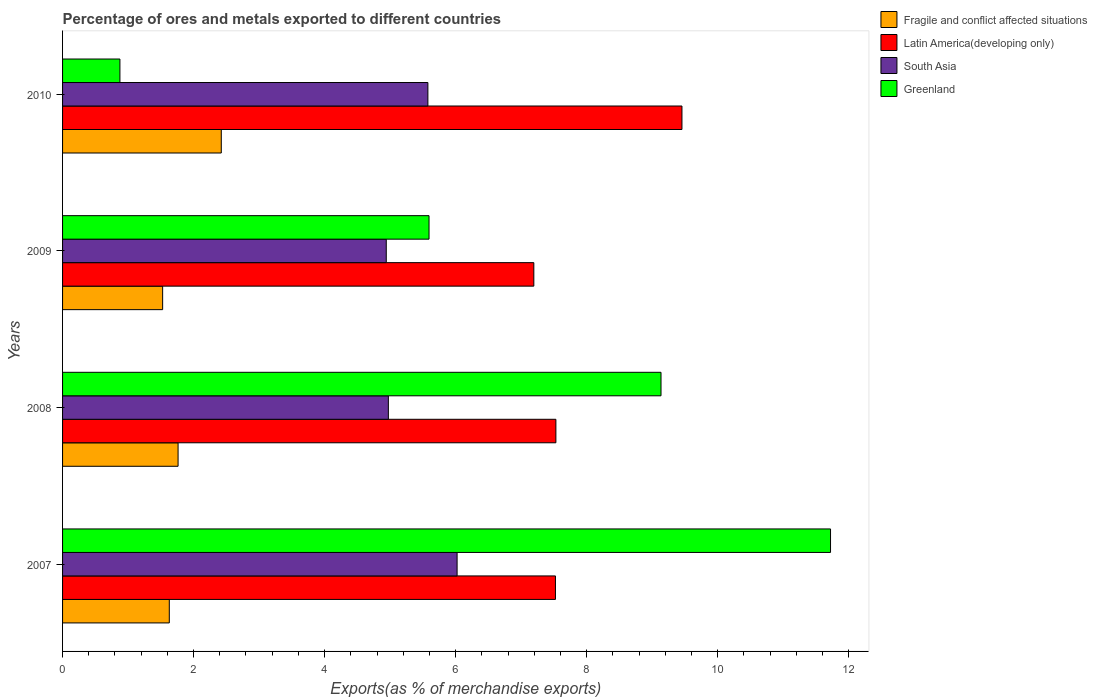How many different coloured bars are there?
Keep it short and to the point. 4. How many bars are there on the 3rd tick from the bottom?
Your answer should be compact. 4. What is the label of the 2nd group of bars from the top?
Offer a very short reply. 2009. In how many cases, is the number of bars for a given year not equal to the number of legend labels?
Provide a short and direct response. 0. What is the percentage of exports to different countries in Latin America(developing only) in 2009?
Your response must be concise. 7.19. Across all years, what is the maximum percentage of exports to different countries in Greenland?
Give a very brief answer. 11.72. Across all years, what is the minimum percentage of exports to different countries in Fragile and conflict affected situations?
Your response must be concise. 1.53. What is the total percentage of exports to different countries in South Asia in the graph?
Your response must be concise. 21.51. What is the difference between the percentage of exports to different countries in South Asia in 2009 and that in 2010?
Provide a short and direct response. -0.64. What is the difference between the percentage of exports to different countries in Fragile and conflict affected situations in 2010 and the percentage of exports to different countries in South Asia in 2007?
Offer a very short reply. -3.6. What is the average percentage of exports to different countries in Fragile and conflict affected situations per year?
Keep it short and to the point. 1.84. In the year 2007, what is the difference between the percentage of exports to different countries in Latin America(developing only) and percentage of exports to different countries in Fragile and conflict affected situations?
Ensure brevity in your answer.  5.89. What is the ratio of the percentage of exports to different countries in Latin America(developing only) in 2008 to that in 2009?
Provide a short and direct response. 1.05. What is the difference between the highest and the second highest percentage of exports to different countries in Fragile and conflict affected situations?
Your answer should be very brief. 0.66. What is the difference between the highest and the lowest percentage of exports to different countries in South Asia?
Provide a short and direct response. 1.08. In how many years, is the percentage of exports to different countries in Greenland greater than the average percentage of exports to different countries in Greenland taken over all years?
Ensure brevity in your answer.  2. What does the 1st bar from the top in 2010 represents?
Provide a short and direct response. Greenland. What does the 2nd bar from the bottom in 2007 represents?
Keep it short and to the point. Latin America(developing only). How many years are there in the graph?
Offer a very short reply. 4. Are the values on the major ticks of X-axis written in scientific E-notation?
Make the answer very short. No. Does the graph contain any zero values?
Ensure brevity in your answer.  No. Does the graph contain grids?
Offer a terse response. No. How are the legend labels stacked?
Give a very brief answer. Vertical. What is the title of the graph?
Offer a terse response. Percentage of ores and metals exported to different countries. What is the label or title of the X-axis?
Keep it short and to the point. Exports(as % of merchandise exports). What is the label or title of the Y-axis?
Offer a terse response. Years. What is the Exports(as % of merchandise exports) in Fragile and conflict affected situations in 2007?
Ensure brevity in your answer.  1.63. What is the Exports(as % of merchandise exports) of Latin America(developing only) in 2007?
Offer a terse response. 7.52. What is the Exports(as % of merchandise exports) in South Asia in 2007?
Your answer should be very brief. 6.02. What is the Exports(as % of merchandise exports) of Greenland in 2007?
Your response must be concise. 11.72. What is the Exports(as % of merchandise exports) in Fragile and conflict affected situations in 2008?
Ensure brevity in your answer.  1.76. What is the Exports(as % of merchandise exports) of Latin America(developing only) in 2008?
Give a very brief answer. 7.53. What is the Exports(as % of merchandise exports) in South Asia in 2008?
Provide a succinct answer. 4.97. What is the Exports(as % of merchandise exports) in Greenland in 2008?
Offer a very short reply. 9.14. What is the Exports(as % of merchandise exports) of Fragile and conflict affected situations in 2009?
Offer a terse response. 1.53. What is the Exports(as % of merchandise exports) of Latin America(developing only) in 2009?
Offer a very short reply. 7.19. What is the Exports(as % of merchandise exports) of South Asia in 2009?
Keep it short and to the point. 4.94. What is the Exports(as % of merchandise exports) of Greenland in 2009?
Offer a terse response. 5.59. What is the Exports(as % of merchandise exports) in Fragile and conflict affected situations in 2010?
Your response must be concise. 2.42. What is the Exports(as % of merchandise exports) of Latin America(developing only) in 2010?
Your answer should be very brief. 9.46. What is the Exports(as % of merchandise exports) in South Asia in 2010?
Offer a terse response. 5.58. What is the Exports(as % of merchandise exports) in Greenland in 2010?
Keep it short and to the point. 0.88. Across all years, what is the maximum Exports(as % of merchandise exports) of Fragile and conflict affected situations?
Provide a succinct answer. 2.42. Across all years, what is the maximum Exports(as % of merchandise exports) in Latin America(developing only)?
Provide a succinct answer. 9.46. Across all years, what is the maximum Exports(as % of merchandise exports) in South Asia?
Your response must be concise. 6.02. Across all years, what is the maximum Exports(as % of merchandise exports) of Greenland?
Keep it short and to the point. 11.72. Across all years, what is the minimum Exports(as % of merchandise exports) of Fragile and conflict affected situations?
Make the answer very short. 1.53. Across all years, what is the minimum Exports(as % of merchandise exports) in Latin America(developing only)?
Offer a terse response. 7.19. Across all years, what is the minimum Exports(as % of merchandise exports) in South Asia?
Ensure brevity in your answer.  4.94. Across all years, what is the minimum Exports(as % of merchandise exports) in Greenland?
Keep it short and to the point. 0.88. What is the total Exports(as % of merchandise exports) in Fragile and conflict affected situations in the graph?
Provide a succinct answer. 7.34. What is the total Exports(as % of merchandise exports) in Latin America(developing only) in the graph?
Your response must be concise. 31.7. What is the total Exports(as % of merchandise exports) in South Asia in the graph?
Provide a succinct answer. 21.51. What is the total Exports(as % of merchandise exports) in Greenland in the graph?
Your answer should be very brief. 27.33. What is the difference between the Exports(as % of merchandise exports) of Fragile and conflict affected situations in 2007 and that in 2008?
Ensure brevity in your answer.  -0.13. What is the difference between the Exports(as % of merchandise exports) in Latin America(developing only) in 2007 and that in 2008?
Your response must be concise. -0.01. What is the difference between the Exports(as % of merchandise exports) of South Asia in 2007 and that in 2008?
Offer a terse response. 1.05. What is the difference between the Exports(as % of merchandise exports) of Greenland in 2007 and that in 2008?
Your answer should be very brief. 2.59. What is the difference between the Exports(as % of merchandise exports) in Fragile and conflict affected situations in 2007 and that in 2009?
Ensure brevity in your answer.  0.1. What is the difference between the Exports(as % of merchandise exports) of Latin America(developing only) in 2007 and that in 2009?
Provide a short and direct response. 0.33. What is the difference between the Exports(as % of merchandise exports) of South Asia in 2007 and that in 2009?
Offer a very short reply. 1.08. What is the difference between the Exports(as % of merchandise exports) in Greenland in 2007 and that in 2009?
Provide a short and direct response. 6.13. What is the difference between the Exports(as % of merchandise exports) in Fragile and conflict affected situations in 2007 and that in 2010?
Provide a succinct answer. -0.79. What is the difference between the Exports(as % of merchandise exports) of Latin America(developing only) in 2007 and that in 2010?
Your answer should be compact. -1.93. What is the difference between the Exports(as % of merchandise exports) of South Asia in 2007 and that in 2010?
Keep it short and to the point. 0.45. What is the difference between the Exports(as % of merchandise exports) of Greenland in 2007 and that in 2010?
Provide a succinct answer. 10.85. What is the difference between the Exports(as % of merchandise exports) of Fragile and conflict affected situations in 2008 and that in 2009?
Give a very brief answer. 0.24. What is the difference between the Exports(as % of merchandise exports) in Latin America(developing only) in 2008 and that in 2009?
Make the answer very short. 0.34. What is the difference between the Exports(as % of merchandise exports) in South Asia in 2008 and that in 2009?
Make the answer very short. 0.03. What is the difference between the Exports(as % of merchandise exports) in Greenland in 2008 and that in 2009?
Offer a very short reply. 3.54. What is the difference between the Exports(as % of merchandise exports) in Fragile and conflict affected situations in 2008 and that in 2010?
Offer a very short reply. -0.66. What is the difference between the Exports(as % of merchandise exports) in Latin America(developing only) in 2008 and that in 2010?
Give a very brief answer. -1.92. What is the difference between the Exports(as % of merchandise exports) in South Asia in 2008 and that in 2010?
Ensure brevity in your answer.  -0.6. What is the difference between the Exports(as % of merchandise exports) of Greenland in 2008 and that in 2010?
Make the answer very short. 8.26. What is the difference between the Exports(as % of merchandise exports) of Fragile and conflict affected situations in 2009 and that in 2010?
Offer a terse response. -0.9. What is the difference between the Exports(as % of merchandise exports) in Latin America(developing only) in 2009 and that in 2010?
Offer a very short reply. -2.26. What is the difference between the Exports(as % of merchandise exports) of South Asia in 2009 and that in 2010?
Offer a very short reply. -0.64. What is the difference between the Exports(as % of merchandise exports) in Greenland in 2009 and that in 2010?
Offer a very short reply. 4.72. What is the difference between the Exports(as % of merchandise exports) in Fragile and conflict affected situations in 2007 and the Exports(as % of merchandise exports) in Latin America(developing only) in 2008?
Provide a short and direct response. -5.9. What is the difference between the Exports(as % of merchandise exports) in Fragile and conflict affected situations in 2007 and the Exports(as % of merchandise exports) in South Asia in 2008?
Your answer should be compact. -3.34. What is the difference between the Exports(as % of merchandise exports) of Fragile and conflict affected situations in 2007 and the Exports(as % of merchandise exports) of Greenland in 2008?
Ensure brevity in your answer.  -7.51. What is the difference between the Exports(as % of merchandise exports) in Latin America(developing only) in 2007 and the Exports(as % of merchandise exports) in South Asia in 2008?
Your response must be concise. 2.55. What is the difference between the Exports(as % of merchandise exports) of Latin America(developing only) in 2007 and the Exports(as % of merchandise exports) of Greenland in 2008?
Ensure brevity in your answer.  -1.61. What is the difference between the Exports(as % of merchandise exports) of South Asia in 2007 and the Exports(as % of merchandise exports) of Greenland in 2008?
Offer a terse response. -3.11. What is the difference between the Exports(as % of merchandise exports) in Fragile and conflict affected situations in 2007 and the Exports(as % of merchandise exports) in Latin America(developing only) in 2009?
Your response must be concise. -5.56. What is the difference between the Exports(as % of merchandise exports) in Fragile and conflict affected situations in 2007 and the Exports(as % of merchandise exports) in South Asia in 2009?
Your answer should be compact. -3.31. What is the difference between the Exports(as % of merchandise exports) of Fragile and conflict affected situations in 2007 and the Exports(as % of merchandise exports) of Greenland in 2009?
Your response must be concise. -3.96. What is the difference between the Exports(as % of merchandise exports) in Latin America(developing only) in 2007 and the Exports(as % of merchandise exports) in South Asia in 2009?
Your answer should be very brief. 2.58. What is the difference between the Exports(as % of merchandise exports) in Latin America(developing only) in 2007 and the Exports(as % of merchandise exports) in Greenland in 2009?
Provide a succinct answer. 1.93. What is the difference between the Exports(as % of merchandise exports) of South Asia in 2007 and the Exports(as % of merchandise exports) of Greenland in 2009?
Your answer should be very brief. 0.43. What is the difference between the Exports(as % of merchandise exports) in Fragile and conflict affected situations in 2007 and the Exports(as % of merchandise exports) in Latin America(developing only) in 2010?
Offer a terse response. -7.83. What is the difference between the Exports(as % of merchandise exports) of Fragile and conflict affected situations in 2007 and the Exports(as % of merchandise exports) of South Asia in 2010?
Your answer should be very brief. -3.95. What is the difference between the Exports(as % of merchandise exports) in Fragile and conflict affected situations in 2007 and the Exports(as % of merchandise exports) in Greenland in 2010?
Provide a succinct answer. 0.75. What is the difference between the Exports(as % of merchandise exports) in Latin America(developing only) in 2007 and the Exports(as % of merchandise exports) in South Asia in 2010?
Ensure brevity in your answer.  1.95. What is the difference between the Exports(as % of merchandise exports) in Latin America(developing only) in 2007 and the Exports(as % of merchandise exports) in Greenland in 2010?
Provide a short and direct response. 6.65. What is the difference between the Exports(as % of merchandise exports) of South Asia in 2007 and the Exports(as % of merchandise exports) of Greenland in 2010?
Offer a terse response. 5.15. What is the difference between the Exports(as % of merchandise exports) in Fragile and conflict affected situations in 2008 and the Exports(as % of merchandise exports) in Latin America(developing only) in 2009?
Offer a terse response. -5.43. What is the difference between the Exports(as % of merchandise exports) in Fragile and conflict affected situations in 2008 and the Exports(as % of merchandise exports) in South Asia in 2009?
Your response must be concise. -3.18. What is the difference between the Exports(as % of merchandise exports) in Fragile and conflict affected situations in 2008 and the Exports(as % of merchandise exports) in Greenland in 2009?
Your answer should be very brief. -3.83. What is the difference between the Exports(as % of merchandise exports) in Latin America(developing only) in 2008 and the Exports(as % of merchandise exports) in South Asia in 2009?
Your response must be concise. 2.59. What is the difference between the Exports(as % of merchandise exports) of Latin America(developing only) in 2008 and the Exports(as % of merchandise exports) of Greenland in 2009?
Offer a terse response. 1.94. What is the difference between the Exports(as % of merchandise exports) in South Asia in 2008 and the Exports(as % of merchandise exports) in Greenland in 2009?
Provide a short and direct response. -0.62. What is the difference between the Exports(as % of merchandise exports) of Fragile and conflict affected situations in 2008 and the Exports(as % of merchandise exports) of Latin America(developing only) in 2010?
Give a very brief answer. -7.69. What is the difference between the Exports(as % of merchandise exports) of Fragile and conflict affected situations in 2008 and the Exports(as % of merchandise exports) of South Asia in 2010?
Your answer should be compact. -3.81. What is the difference between the Exports(as % of merchandise exports) in Fragile and conflict affected situations in 2008 and the Exports(as % of merchandise exports) in Greenland in 2010?
Offer a very short reply. 0.89. What is the difference between the Exports(as % of merchandise exports) of Latin America(developing only) in 2008 and the Exports(as % of merchandise exports) of South Asia in 2010?
Keep it short and to the point. 1.95. What is the difference between the Exports(as % of merchandise exports) of Latin America(developing only) in 2008 and the Exports(as % of merchandise exports) of Greenland in 2010?
Give a very brief answer. 6.66. What is the difference between the Exports(as % of merchandise exports) in South Asia in 2008 and the Exports(as % of merchandise exports) in Greenland in 2010?
Provide a short and direct response. 4.1. What is the difference between the Exports(as % of merchandise exports) in Fragile and conflict affected situations in 2009 and the Exports(as % of merchandise exports) in Latin America(developing only) in 2010?
Your answer should be compact. -7.93. What is the difference between the Exports(as % of merchandise exports) of Fragile and conflict affected situations in 2009 and the Exports(as % of merchandise exports) of South Asia in 2010?
Keep it short and to the point. -4.05. What is the difference between the Exports(as % of merchandise exports) in Fragile and conflict affected situations in 2009 and the Exports(as % of merchandise exports) in Greenland in 2010?
Offer a very short reply. 0.65. What is the difference between the Exports(as % of merchandise exports) in Latin America(developing only) in 2009 and the Exports(as % of merchandise exports) in South Asia in 2010?
Your answer should be very brief. 1.62. What is the difference between the Exports(as % of merchandise exports) in Latin America(developing only) in 2009 and the Exports(as % of merchandise exports) in Greenland in 2010?
Provide a succinct answer. 6.32. What is the difference between the Exports(as % of merchandise exports) of South Asia in 2009 and the Exports(as % of merchandise exports) of Greenland in 2010?
Provide a succinct answer. 4.07. What is the average Exports(as % of merchandise exports) in Fragile and conflict affected situations per year?
Offer a terse response. 1.84. What is the average Exports(as % of merchandise exports) in Latin America(developing only) per year?
Provide a short and direct response. 7.93. What is the average Exports(as % of merchandise exports) of South Asia per year?
Make the answer very short. 5.38. What is the average Exports(as % of merchandise exports) of Greenland per year?
Make the answer very short. 6.83. In the year 2007, what is the difference between the Exports(as % of merchandise exports) of Fragile and conflict affected situations and Exports(as % of merchandise exports) of Latin America(developing only)?
Your response must be concise. -5.89. In the year 2007, what is the difference between the Exports(as % of merchandise exports) in Fragile and conflict affected situations and Exports(as % of merchandise exports) in South Asia?
Provide a succinct answer. -4.39. In the year 2007, what is the difference between the Exports(as % of merchandise exports) in Fragile and conflict affected situations and Exports(as % of merchandise exports) in Greenland?
Your response must be concise. -10.09. In the year 2007, what is the difference between the Exports(as % of merchandise exports) of Latin America(developing only) and Exports(as % of merchandise exports) of South Asia?
Keep it short and to the point. 1.5. In the year 2007, what is the difference between the Exports(as % of merchandise exports) of Latin America(developing only) and Exports(as % of merchandise exports) of Greenland?
Give a very brief answer. -4.2. In the year 2007, what is the difference between the Exports(as % of merchandise exports) in South Asia and Exports(as % of merchandise exports) in Greenland?
Offer a terse response. -5.7. In the year 2008, what is the difference between the Exports(as % of merchandise exports) in Fragile and conflict affected situations and Exports(as % of merchandise exports) in Latin America(developing only)?
Your answer should be very brief. -5.77. In the year 2008, what is the difference between the Exports(as % of merchandise exports) in Fragile and conflict affected situations and Exports(as % of merchandise exports) in South Asia?
Your answer should be very brief. -3.21. In the year 2008, what is the difference between the Exports(as % of merchandise exports) in Fragile and conflict affected situations and Exports(as % of merchandise exports) in Greenland?
Your response must be concise. -7.37. In the year 2008, what is the difference between the Exports(as % of merchandise exports) of Latin America(developing only) and Exports(as % of merchandise exports) of South Asia?
Provide a succinct answer. 2.56. In the year 2008, what is the difference between the Exports(as % of merchandise exports) of Latin America(developing only) and Exports(as % of merchandise exports) of Greenland?
Provide a short and direct response. -1.6. In the year 2008, what is the difference between the Exports(as % of merchandise exports) of South Asia and Exports(as % of merchandise exports) of Greenland?
Offer a very short reply. -4.16. In the year 2009, what is the difference between the Exports(as % of merchandise exports) of Fragile and conflict affected situations and Exports(as % of merchandise exports) of Latin America(developing only)?
Provide a short and direct response. -5.67. In the year 2009, what is the difference between the Exports(as % of merchandise exports) in Fragile and conflict affected situations and Exports(as % of merchandise exports) in South Asia?
Give a very brief answer. -3.41. In the year 2009, what is the difference between the Exports(as % of merchandise exports) in Fragile and conflict affected situations and Exports(as % of merchandise exports) in Greenland?
Provide a short and direct response. -4.07. In the year 2009, what is the difference between the Exports(as % of merchandise exports) of Latin America(developing only) and Exports(as % of merchandise exports) of South Asia?
Your answer should be very brief. 2.25. In the year 2009, what is the difference between the Exports(as % of merchandise exports) of Latin America(developing only) and Exports(as % of merchandise exports) of Greenland?
Keep it short and to the point. 1.6. In the year 2009, what is the difference between the Exports(as % of merchandise exports) in South Asia and Exports(as % of merchandise exports) in Greenland?
Keep it short and to the point. -0.65. In the year 2010, what is the difference between the Exports(as % of merchandise exports) of Fragile and conflict affected situations and Exports(as % of merchandise exports) of Latin America(developing only)?
Ensure brevity in your answer.  -7.03. In the year 2010, what is the difference between the Exports(as % of merchandise exports) of Fragile and conflict affected situations and Exports(as % of merchandise exports) of South Asia?
Offer a very short reply. -3.15. In the year 2010, what is the difference between the Exports(as % of merchandise exports) of Fragile and conflict affected situations and Exports(as % of merchandise exports) of Greenland?
Ensure brevity in your answer.  1.55. In the year 2010, what is the difference between the Exports(as % of merchandise exports) in Latin America(developing only) and Exports(as % of merchandise exports) in South Asia?
Ensure brevity in your answer.  3.88. In the year 2010, what is the difference between the Exports(as % of merchandise exports) of Latin America(developing only) and Exports(as % of merchandise exports) of Greenland?
Offer a terse response. 8.58. In the year 2010, what is the difference between the Exports(as % of merchandise exports) in South Asia and Exports(as % of merchandise exports) in Greenland?
Offer a very short reply. 4.7. What is the ratio of the Exports(as % of merchandise exports) of Fragile and conflict affected situations in 2007 to that in 2008?
Provide a short and direct response. 0.92. What is the ratio of the Exports(as % of merchandise exports) in Latin America(developing only) in 2007 to that in 2008?
Your response must be concise. 1. What is the ratio of the Exports(as % of merchandise exports) of South Asia in 2007 to that in 2008?
Offer a very short reply. 1.21. What is the ratio of the Exports(as % of merchandise exports) in Greenland in 2007 to that in 2008?
Keep it short and to the point. 1.28. What is the ratio of the Exports(as % of merchandise exports) in Fragile and conflict affected situations in 2007 to that in 2009?
Offer a terse response. 1.07. What is the ratio of the Exports(as % of merchandise exports) in Latin America(developing only) in 2007 to that in 2009?
Your answer should be compact. 1.05. What is the ratio of the Exports(as % of merchandise exports) in South Asia in 2007 to that in 2009?
Offer a very short reply. 1.22. What is the ratio of the Exports(as % of merchandise exports) in Greenland in 2007 to that in 2009?
Your answer should be compact. 2.1. What is the ratio of the Exports(as % of merchandise exports) in Fragile and conflict affected situations in 2007 to that in 2010?
Keep it short and to the point. 0.67. What is the ratio of the Exports(as % of merchandise exports) of Latin America(developing only) in 2007 to that in 2010?
Provide a short and direct response. 0.8. What is the ratio of the Exports(as % of merchandise exports) of Greenland in 2007 to that in 2010?
Your response must be concise. 13.39. What is the ratio of the Exports(as % of merchandise exports) of Fragile and conflict affected situations in 2008 to that in 2009?
Give a very brief answer. 1.15. What is the ratio of the Exports(as % of merchandise exports) of Latin America(developing only) in 2008 to that in 2009?
Offer a terse response. 1.05. What is the ratio of the Exports(as % of merchandise exports) in Greenland in 2008 to that in 2009?
Ensure brevity in your answer.  1.63. What is the ratio of the Exports(as % of merchandise exports) of Fragile and conflict affected situations in 2008 to that in 2010?
Provide a succinct answer. 0.73. What is the ratio of the Exports(as % of merchandise exports) in Latin America(developing only) in 2008 to that in 2010?
Provide a succinct answer. 0.8. What is the ratio of the Exports(as % of merchandise exports) of South Asia in 2008 to that in 2010?
Provide a short and direct response. 0.89. What is the ratio of the Exports(as % of merchandise exports) of Greenland in 2008 to that in 2010?
Provide a short and direct response. 10.43. What is the ratio of the Exports(as % of merchandise exports) of Fragile and conflict affected situations in 2009 to that in 2010?
Your answer should be very brief. 0.63. What is the ratio of the Exports(as % of merchandise exports) of Latin America(developing only) in 2009 to that in 2010?
Your response must be concise. 0.76. What is the ratio of the Exports(as % of merchandise exports) of South Asia in 2009 to that in 2010?
Provide a succinct answer. 0.89. What is the ratio of the Exports(as % of merchandise exports) in Greenland in 2009 to that in 2010?
Provide a short and direct response. 6.39. What is the difference between the highest and the second highest Exports(as % of merchandise exports) in Fragile and conflict affected situations?
Your answer should be very brief. 0.66. What is the difference between the highest and the second highest Exports(as % of merchandise exports) in Latin America(developing only)?
Make the answer very short. 1.92. What is the difference between the highest and the second highest Exports(as % of merchandise exports) in South Asia?
Your response must be concise. 0.45. What is the difference between the highest and the second highest Exports(as % of merchandise exports) of Greenland?
Keep it short and to the point. 2.59. What is the difference between the highest and the lowest Exports(as % of merchandise exports) in Fragile and conflict affected situations?
Ensure brevity in your answer.  0.9. What is the difference between the highest and the lowest Exports(as % of merchandise exports) in Latin America(developing only)?
Ensure brevity in your answer.  2.26. What is the difference between the highest and the lowest Exports(as % of merchandise exports) in South Asia?
Give a very brief answer. 1.08. What is the difference between the highest and the lowest Exports(as % of merchandise exports) of Greenland?
Keep it short and to the point. 10.85. 